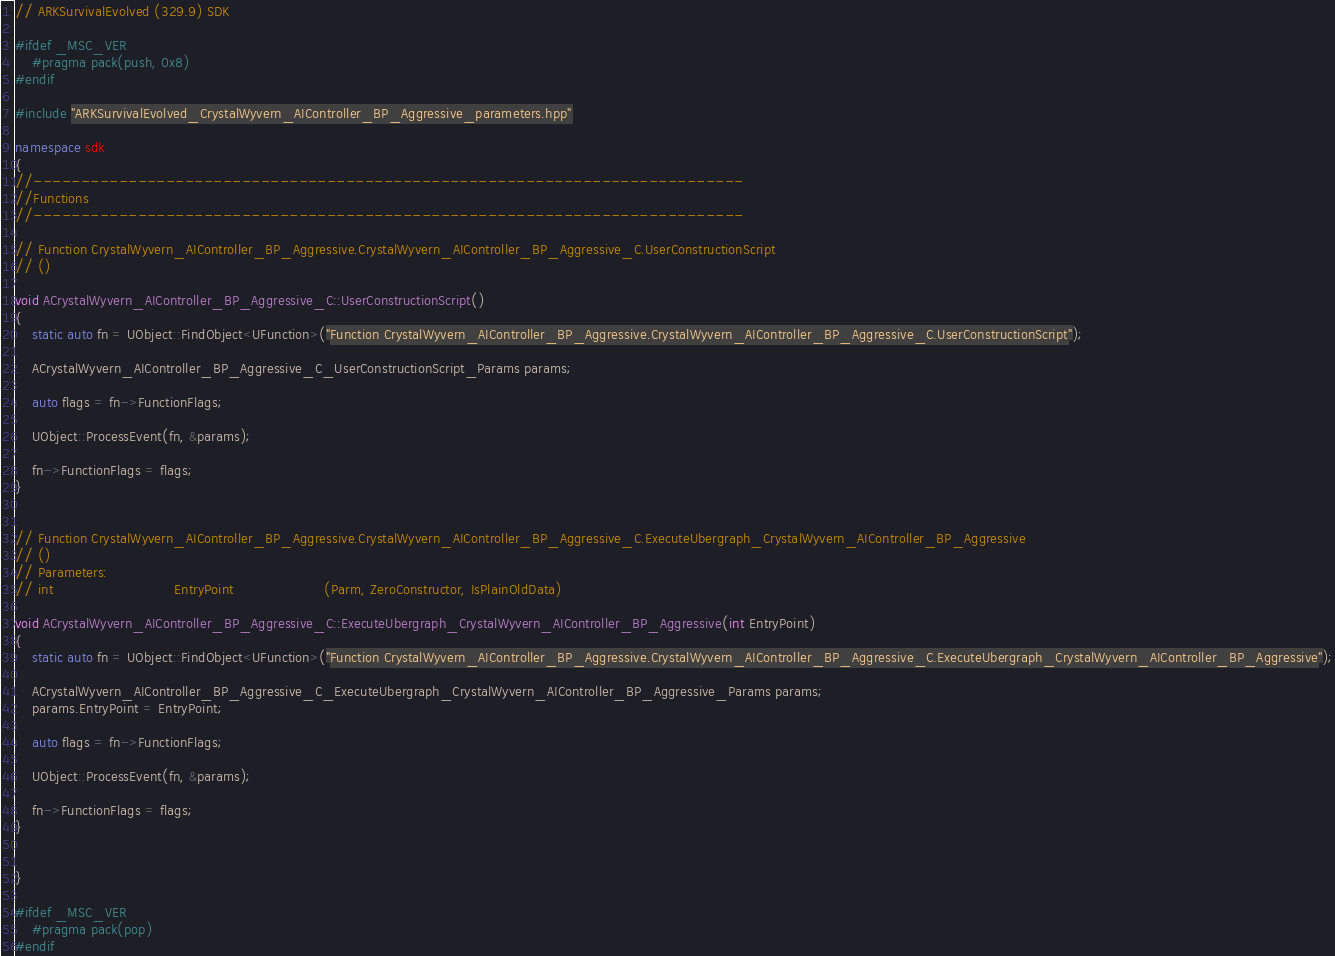<code> <loc_0><loc_0><loc_500><loc_500><_C++_>// ARKSurvivalEvolved (329.9) SDK

#ifdef _MSC_VER
	#pragma pack(push, 0x8)
#endif

#include "ARKSurvivalEvolved_CrystalWyvern_AIController_BP_Aggressive_parameters.hpp"

namespace sdk
{
//---------------------------------------------------------------------------
//Functions
//---------------------------------------------------------------------------

// Function CrystalWyvern_AIController_BP_Aggressive.CrystalWyvern_AIController_BP_Aggressive_C.UserConstructionScript
// ()

void ACrystalWyvern_AIController_BP_Aggressive_C::UserConstructionScript()
{
	static auto fn = UObject::FindObject<UFunction>("Function CrystalWyvern_AIController_BP_Aggressive.CrystalWyvern_AIController_BP_Aggressive_C.UserConstructionScript");

	ACrystalWyvern_AIController_BP_Aggressive_C_UserConstructionScript_Params params;

	auto flags = fn->FunctionFlags;

	UObject::ProcessEvent(fn, &params);

	fn->FunctionFlags = flags;
}


// Function CrystalWyvern_AIController_BP_Aggressive.CrystalWyvern_AIController_BP_Aggressive_C.ExecuteUbergraph_CrystalWyvern_AIController_BP_Aggressive
// ()
// Parameters:
// int                            EntryPoint                     (Parm, ZeroConstructor, IsPlainOldData)

void ACrystalWyvern_AIController_BP_Aggressive_C::ExecuteUbergraph_CrystalWyvern_AIController_BP_Aggressive(int EntryPoint)
{
	static auto fn = UObject::FindObject<UFunction>("Function CrystalWyvern_AIController_BP_Aggressive.CrystalWyvern_AIController_BP_Aggressive_C.ExecuteUbergraph_CrystalWyvern_AIController_BP_Aggressive");

	ACrystalWyvern_AIController_BP_Aggressive_C_ExecuteUbergraph_CrystalWyvern_AIController_BP_Aggressive_Params params;
	params.EntryPoint = EntryPoint;

	auto flags = fn->FunctionFlags;

	UObject::ProcessEvent(fn, &params);

	fn->FunctionFlags = flags;
}


}

#ifdef _MSC_VER
	#pragma pack(pop)
#endif
</code> 